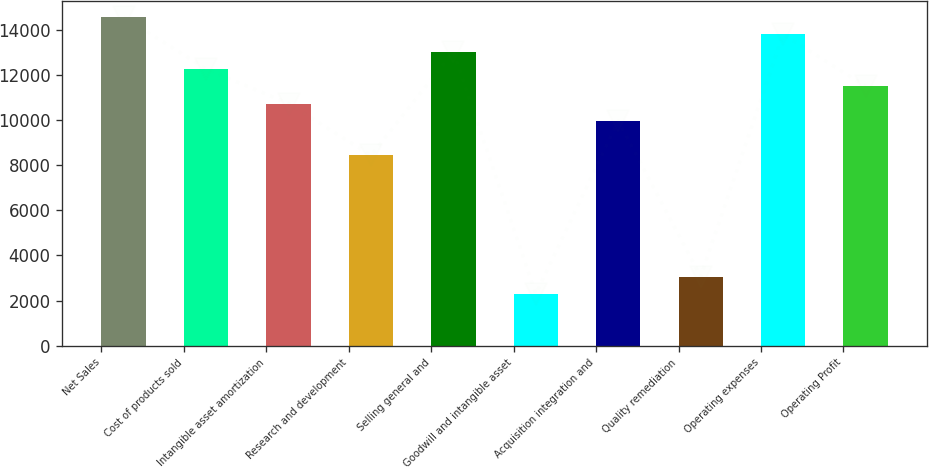Convert chart. <chart><loc_0><loc_0><loc_500><loc_500><bar_chart><fcel>Net Sales<fcel>Cost of products sold<fcel>Intangible asset amortization<fcel>Research and development<fcel>Selling general and<fcel>Goodwill and intangible asset<fcel>Acquisition integration and<fcel>Quality remediation<fcel>Operating expenses<fcel>Operating Profit<nl><fcel>14568.8<fcel>12268.7<fcel>10735.2<fcel>8435.11<fcel>13035.4<fcel>2301.43<fcel>9968.53<fcel>3068.14<fcel>13802.1<fcel>11502<nl></chart> 